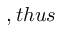<formula> <loc_0><loc_0><loc_500><loc_500>, t h u s</formula> 